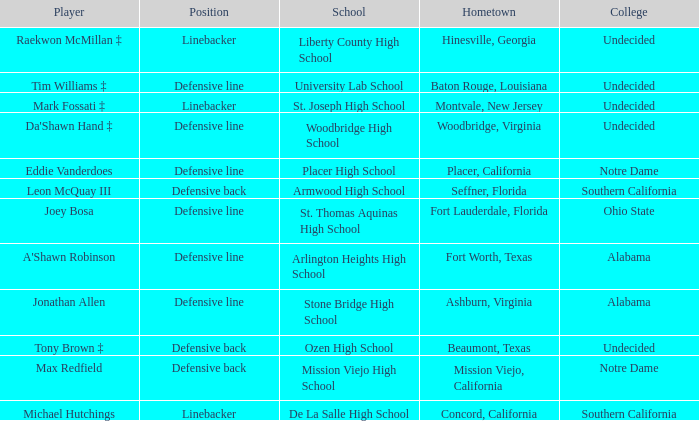What position did Max Redfield play? Defensive back. 